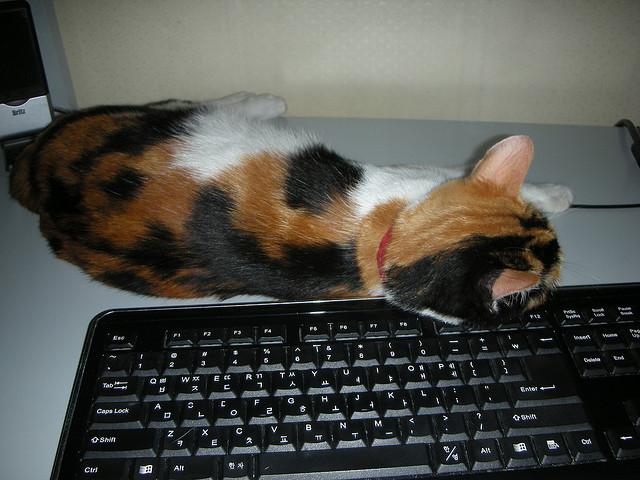Does the keyboard have non-English keys?
Concise answer only. No. What color is the cat's collar?
Be succinct. Red. Is there more than one cat in this picture?
Short answer required. No. 